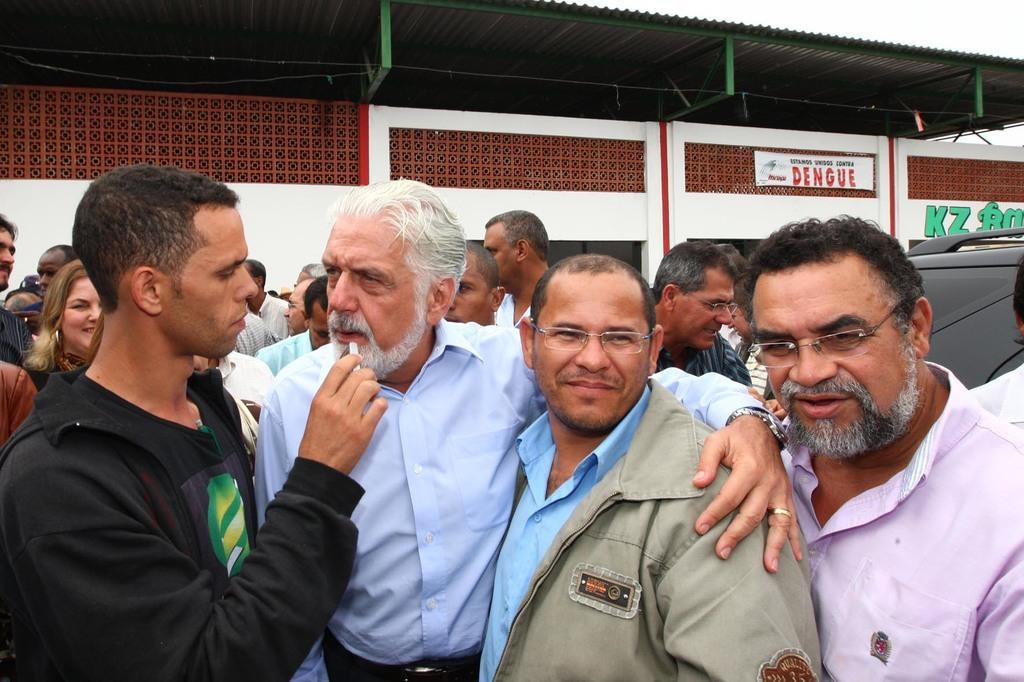What are the people in the image doing? There is a group of people standing in the image. What else can be seen in the image besides the people? There appears to be a vehicle and a building in the image. What is hanging in the image? A banner is hanging in the image. What is located at the top of the image? There is an iron sheet at the top of the image. What type of slip can be seen on the donkey in the image? There is no donkey or slip present in the image. What is being served for lunch in the image? There is no indication of lunch being served in the image. 